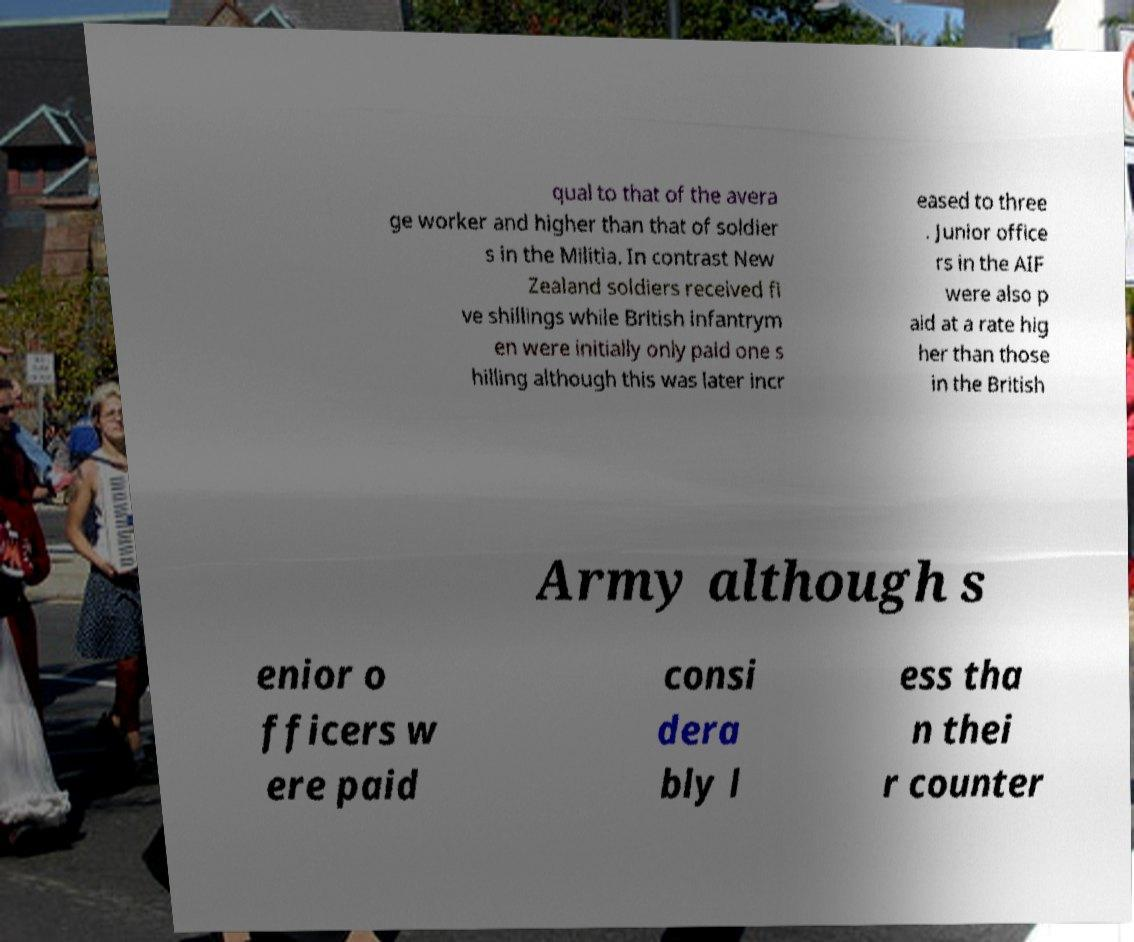I need the written content from this picture converted into text. Can you do that? qual to that of the avera ge worker and higher than that of soldier s in the Militia. In contrast New Zealand soldiers received fi ve shillings while British infantrym en were initially only paid one s hilling although this was later incr eased to three . Junior office rs in the AIF were also p aid at a rate hig her than those in the British Army although s enior o fficers w ere paid consi dera bly l ess tha n thei r counter 